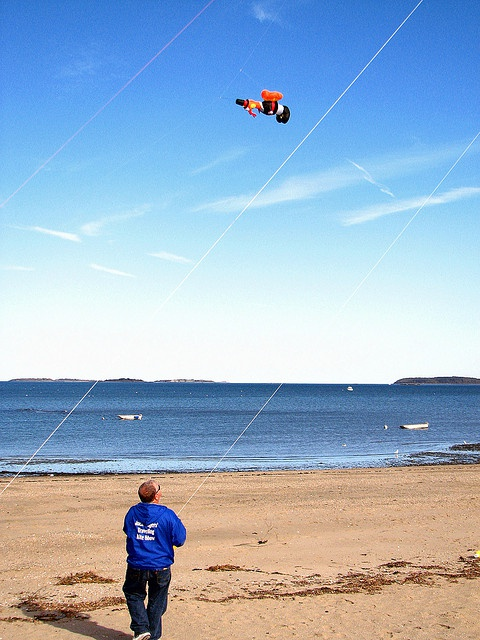Describe the objects in this image and their specific colors. I can see people in blue, black, navy, and darkblue tones, kite in blue, black, red, and white tones, boat in blue, ivory, gray, darkgray, and tan tones, boat in blue, ivory, darkgray, gray, and pink tones, and boat in blue, white, gray, and navy tones in this image. 